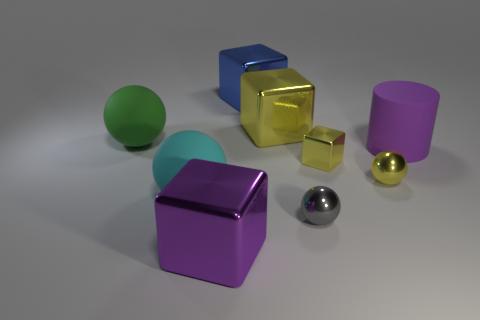Subtract all yellow balls. How many balls are left? 3 Add 1 green cylinders. How many objects exist? 10 Subtract all green spheres. How many spheres are left? 3 Subtract 3 balls. How many balls are left? 1 Subtract 1 yellow spheres. How many objects are left? 8 Subtract all cylinders. How many objects are left? 8 Subtract all yellow balls. Subtract all gray blocks. How many balls are left? 3 Subtract all brown cubes. How many yellow balls are left? 1 Subtract all blocks. Subtract all big cyan rubber balls. How many objects are left? 4 Add 2 big cyan objects. How many big cyan objects are left? 3 